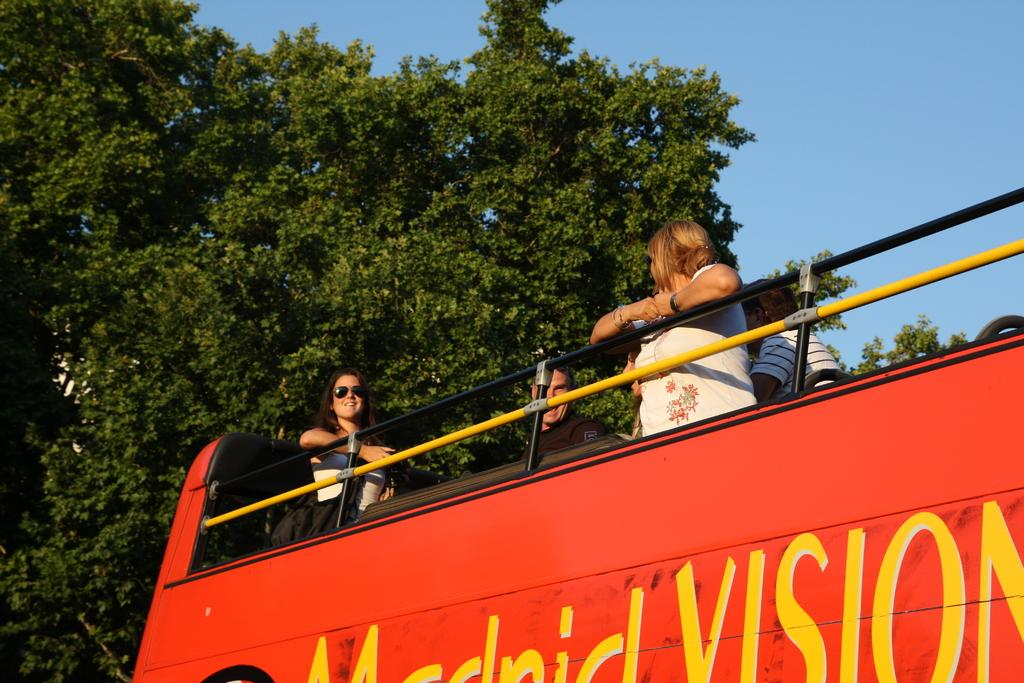What is happening in the image involving people? There are people in a vehicle in the image. What can be seen in the background of the image? There are trees visible in the background of the image. What is the color of the sky in the image? The sky is blue in color. What type of love is being expressed by the trees in the image? There is no love being expressed by the trees in the image, as trees do not have the ability to express emotions. What punishment is being given to the people in the vehicle in the image? There is no punishment being given to the people in the vehicle in the image; they are simply in a vehicle. 